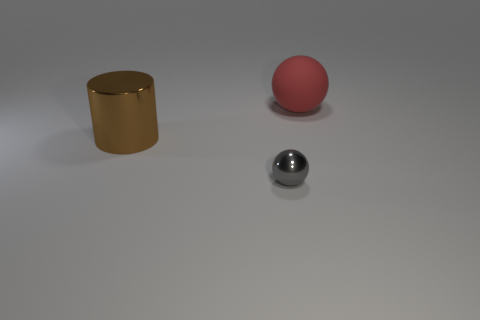What is the shape of the brown object that is the same material as the small sphere?
Ensure brevity in your answer.  Cylinder. There is a large red object; does it have the same shape as the metallic thing that is right of the large metallic thing?
Provide a short and direct response. Yes. What is the material of the big object that is right of the big object that is to the left of the large red sphere?
Offer a terse response. Rubber. What number of other objects are there of the same shape as the big brown object?
Keep it short and to the point. 0. There is a big thing that is right of the gray metallic object; does it have the same shape as the thing in front of the brown metal thing?
Offer a terse response. Yes. Are there any other things that are made of the same material as the tiny sphere?
Your response must be concise. Yes. What is the material of the red sphere?
Give a very brief answer. Rubber. There is a thing that is behind the brown metallic cylinder; what is its material?
Provide a succinct answer. Rubber. What size is the cylinder that is made of the same material as the gray ball?
Your response must be concise. Large. What number of big objects are purple shiny cubes or gray objects?
Keep it short and to the point. 0. 